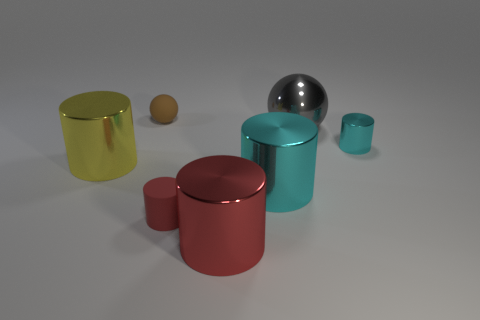Do the large red cylinder and the thing that is behind the gray shiny thing have the same material?
Keep it short and to the point. No. What number of metallic objects are behind the rubber cylinder and in front of the large shiny ball?
Offer a very short reply. 3. There is a gray thing that is the same size as the red metal cylinder; what shape is it?
Ensure brevity in your answer.  Sphere. Are there any large gray metallic balls in front of the big cylinder that is on the left side of the big red metallic cylinder to the right of the brown ball?
Provide a short and direct response. No. There is a tiny matte cylinder; does it have the same color as the big cylinder on the right side of the red metal object?
Make the answer very short. No. What number of large shiny objects have the same color as the rubber cylinder?
Your answer should be very brief. 1. There is a cyan metal cylinder that is right of the cyan thing in front of the yellow thing; what is its size?
Offer a very short reply. Small. What number of things are either large metallic cylinders in front of the tiny red rubber cylinder or matte balls?
Your answer should be compact. 2. Is there a red rubber object that has the same size as the brown matte thing?
Provide a short and direct response. Yes. There is a big object that is left of the red matte object; are there any large cylinders to the right of it?
Provide a short and direct response. Yes. 